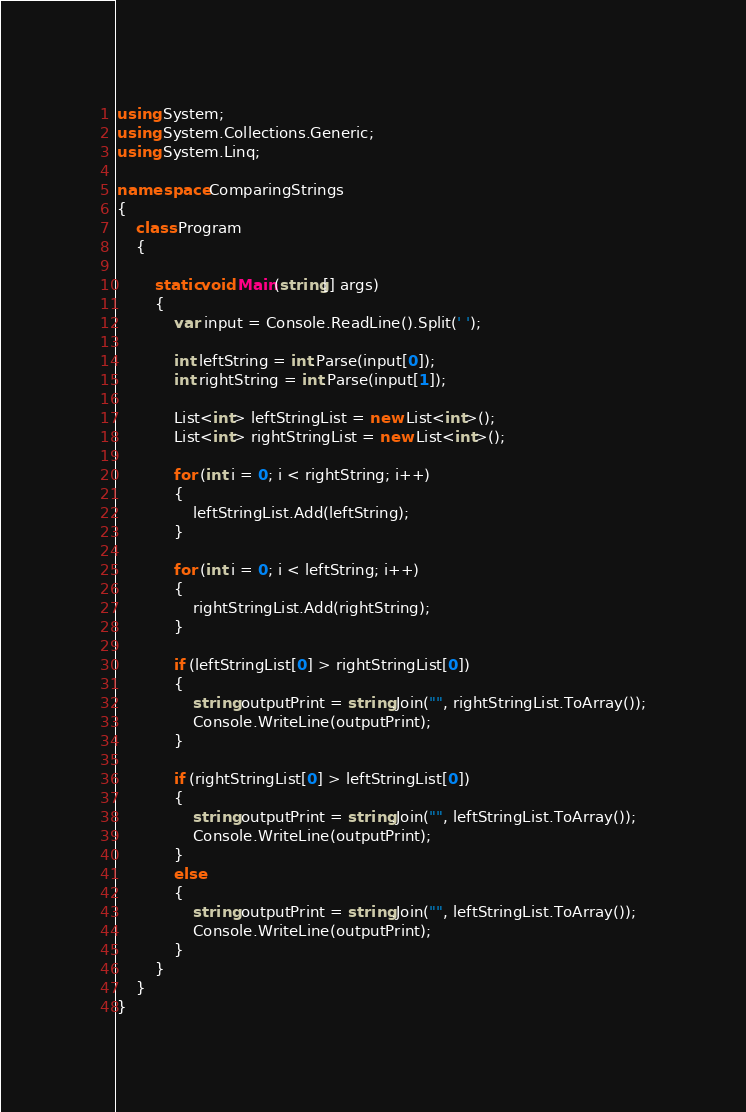<code> <loc_0><loc_0><loc_500><loc_500><_C#_>using System;
using System.Collections.Generic;
using System.Linq;

namespace ComparingStrings
{
    class Program
    {

        static void Main(string[] args)
        {
            var input = Console.ReadLine().Split(' ');

            int leftString = int.Parse(input[0]);
            int rightString = int.Parse(input[1]);

            List<int> leftStringList = new List<int>();
            List<int> rightStringList = new List<int>();

            for (int i = 0; i < rightString; i++)
            {
                leftStringList.Add(leftString);
            }

            for (int i = 0; i < leftString; i++)
            {
                rightStringList.Add(rightString);
            }

            if (leftStringList[0] > rightStringList[0])
            {
                string outputPrint = string.Join("", rightStringList.ToArray());
                Console.WriteLine(outputPrint);
            }

            if (rightStringList[0] > leftStringList[0])
            {
                string outputPrint = string.Join("", leftStringList.ToArray());
                Console.WriteLine(outputPrint);
            }
            else
            {
                string outputPrint = string.Join("", leftStringList.ToArray());
                Console.WriteLine(outputPrint);
            }
        }
    }
}</code> 